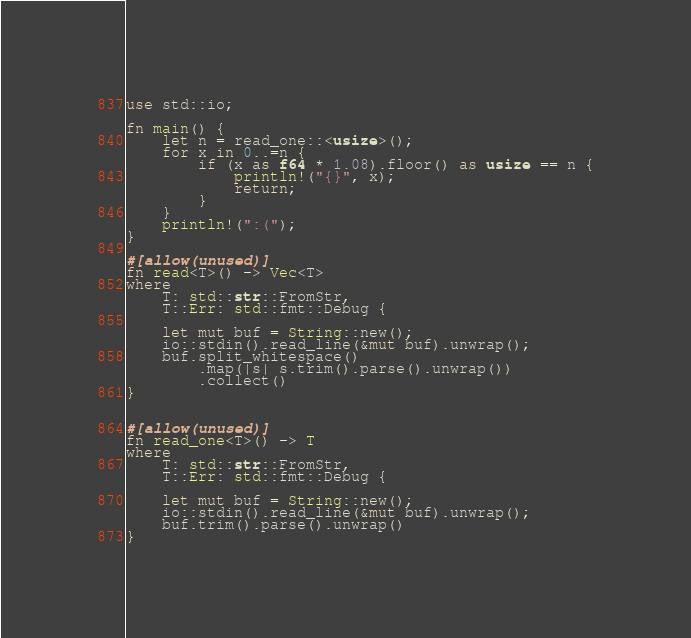Convert code to text. <code><loc_0><loc_0><loc_500><loc_500><_Rust_>use std::io;

fn main() {
    let n = read_one::<usize>();
    for x in 0..=n {
        if (x as f64 * 1.08).floor() as usize == n {
            println!("{}", x);
            return;
        }
    }
    println!(":(");
}

#[allow(unused)]
fn read<T>() -> Vec<T>
where
    T: std::str::FromStr,
    T::Err: std::fmt::Debug {

    let mut buf = String::new();
    io::stdin().read_line(&mut buf).unwrap();
    buf.split_whitespace()
        .map(|s| s.trim().parse().unwrap())
        .collect()
}


#[allow(unused)]
fn read_one<T>() -> T
where
    T: std::str::FromStr,
    T::Err: std::fmt::Debug {

    let mut buf = String::new();
    io::stdin().read_line(&mut buf).unwrap();
    buf.trim().parse().unwrap()
}</code> 